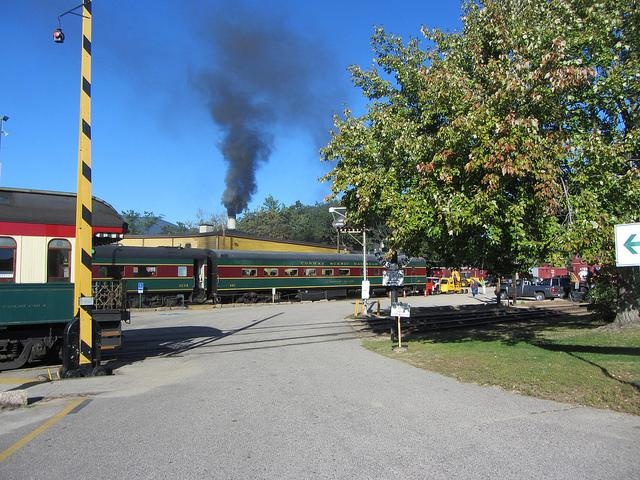In which direction is the train going that is behind the raised arm? Please explain your reasoning. nowhere. The train at the station is not going anywhere at the moment. its smoke is going straight up. 